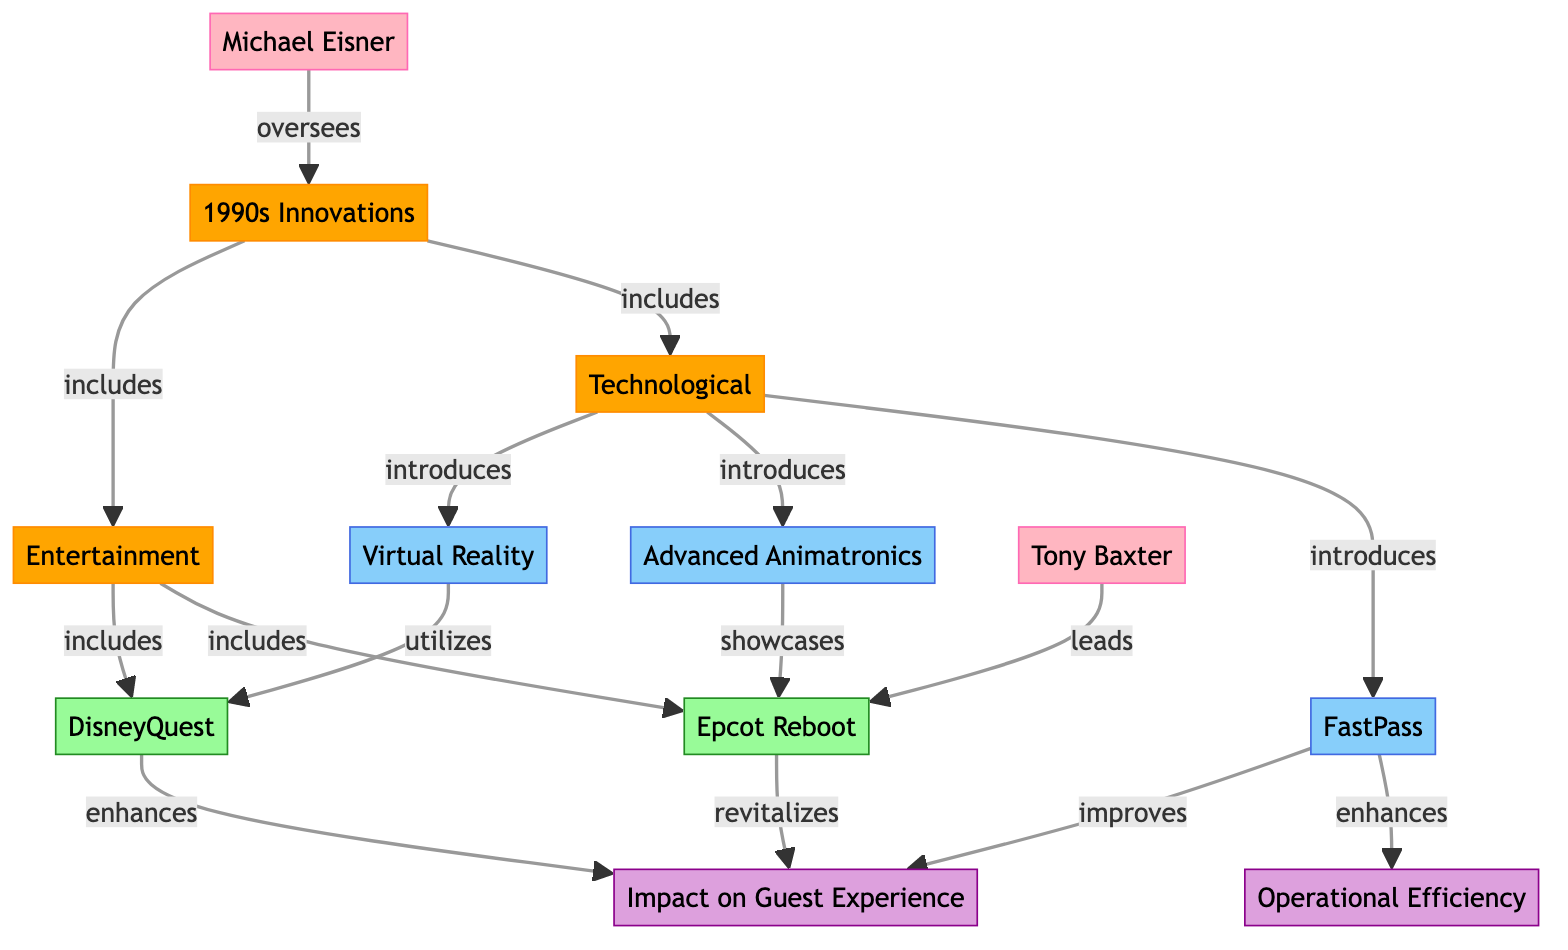What are the two main categories represented in the diagram? The diagram has two main categories: Technological and Entertainment. These are derived from the "1990s Innovations" node as its subcategories, showcasing the different types of innovations introduced during the 1990s at Disney theme parks.
Answer: Technological, Entertainment Which project is associated with Tony Baxter? Tony Baxter is linked to the "Epcot Reboot" node in the diagram, indicating his leadership role in that specific project. This connection showcases the influence he had in shaping this innovation within the Disney theme parks.
Answer: Epcot Reboot How many impacts are represented in the diagram? There are three impacts represented in the diagram: Impact on Guest Experience, Operational Efficiency, and two links leading from innovations to these impacts. Counting the specific impact nodes connected to projects provides this total.
Answer: 2 What enhances Operational Efficiency according to the diagram? "FastPass" is the innovation that enhances Operational Efficiency in the diagram. This connection indicates how FastPass, as a technological innovation, serves to improve the efficiency of park operations.
Answer: FastPass Which innovation utilizes Virtual Reality? The "DisneyQuest" project is linked to "Virtual Reality" in the diagram. This relationship reflects that the DisneyQuest project incorporates Virtual Reality technology in its attractions and experiences.
Answer: DisneyQuest Name one entity that showcases advancements in animatronics. The "Epcot Reboot" project showcases advanced animatronics, as indicated by the link in the diagram from "Animatronics" to "Epcot Reboot". This relationship denotes its role in presenting cutting-edge animatronic technology at this project.
Answer: Epcot Reboot How does FastPass improve guest experience? The diagram indicates that FastPass improves guest experience directly, showing a link between "FastPass" and "Impact on Guest Experience". This suggests that it enhances the way guests experience the parks by reducing wait times.
Answer: improves Who's overseeing the innovations? "Michael Eisner" is the person responsible for overseeing the innovations as per the link from the "Michael Eisner" node to the "Innovations" node in the diagram. This establishes his position in guiding the innovation process at Disney during the 1990s.
Answer: Michael Eisner Which innovation introduced Virtual Reality? The "Technological" category introduces "Virtual Reality" as part of the innovations in the diagram, showcasing how it was one of the new technologies that Disney brought into play during that decade.
Answer: Technological 